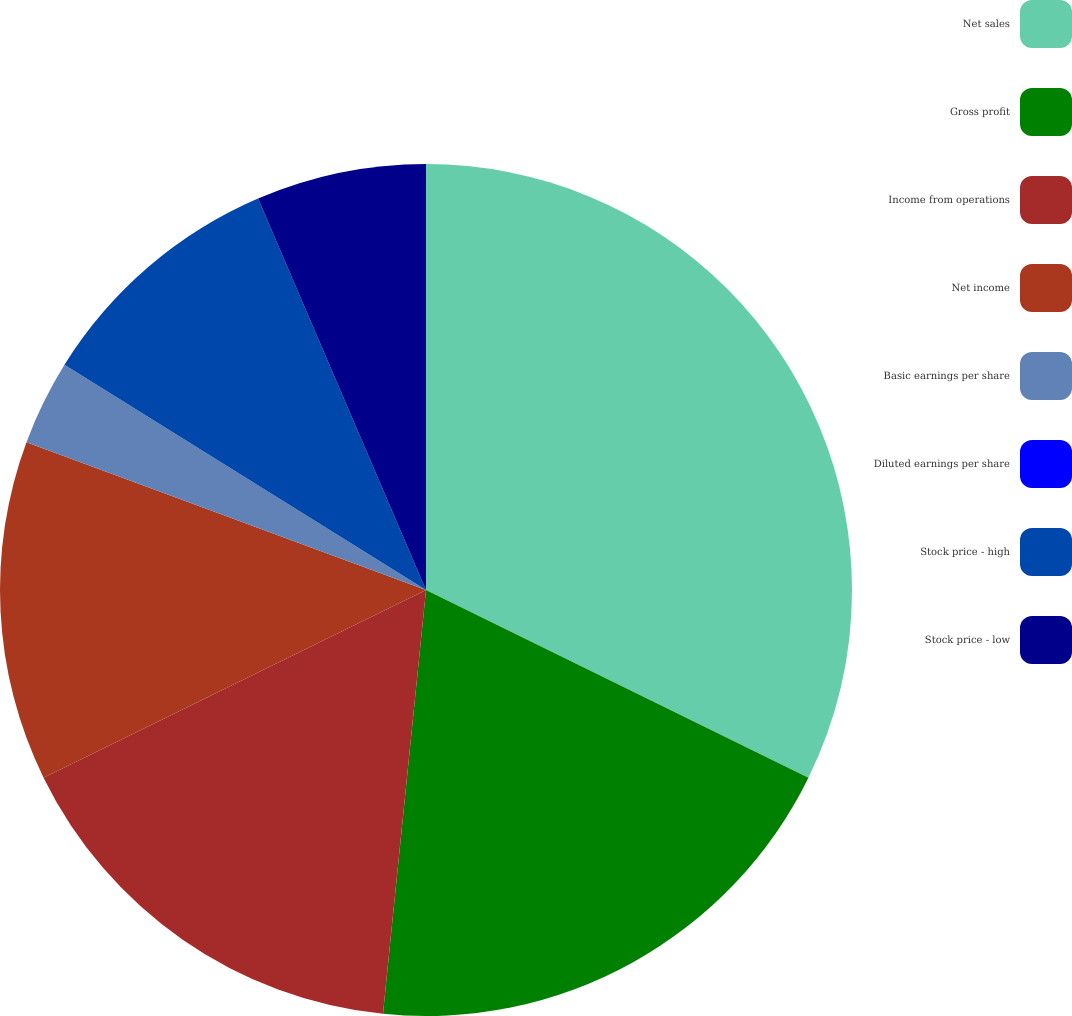Convert chart to OTSL. <chart><loc_0><loc_0><loc_500><loc_500><pie_chart><fcel>Net sales<fcel>Gross profit<fcel>Income from operations<fcel>Net income<fcel>Basic earnings per share<fcel>Diluted earnings per share<fcel>Stock price - high<fcel>Stock price - low<nl><fcel>32.26%<fcel>19.35%<fcel>16.13%<fcel>12.9%<fcel>3.23%<fcel>0.0%<fcel>9.68%<fcel>6.45%<nl></chart> 